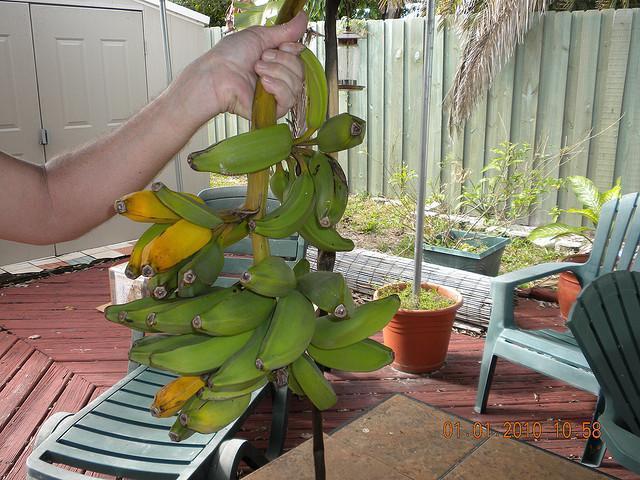How many chairs are there?
Give a very brief answer. 3. How many potted plants are in the picture?
Give a very brief answer. 3. How many of the umbrellas are folded?
Give a very brief answer. 0. 